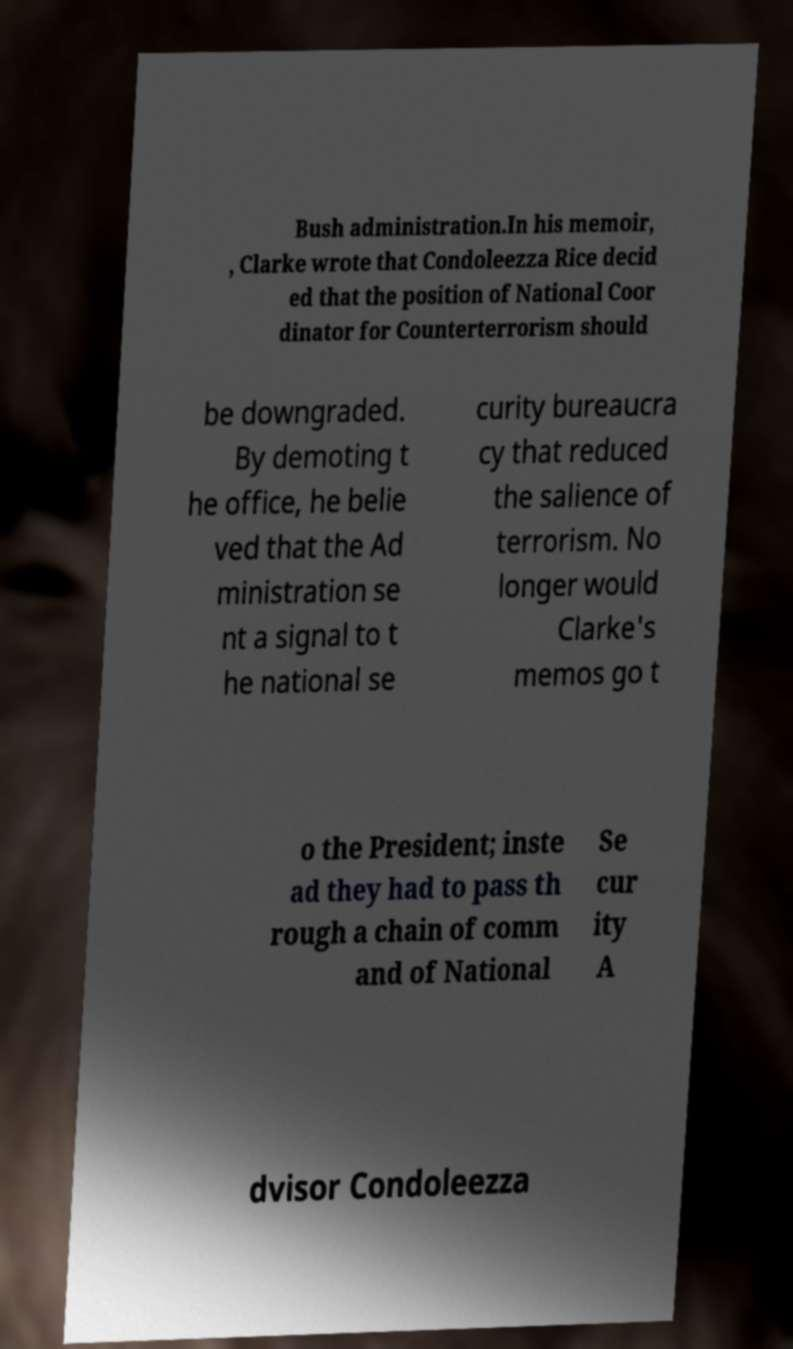Could you assist in decoding the text presented in this image and type it out clearly? Bush administration.In his memoir, , Clarke wrote that Condoleezza Rice decid ed that the position of National Coor dinator for Counterterrorism should be downgraded. By demoting t he office, he belie ved that the Ad ministration se nt a signal to t he national se curity bureaucra cy that reduced the salience of terrorism. No longer would Clarke's memos go t o the President; inste ad they had to pass th rough a chain of comm and of National Se cur ity A dvisor Condoleezza 